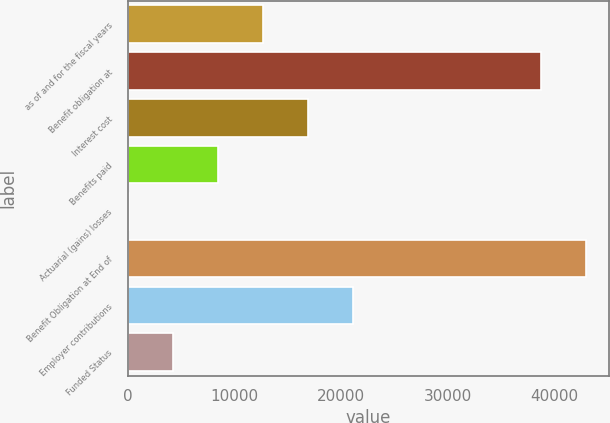Convert chart. <chart><loc_0><loc_0><loc_500><loc_500><bar_chart><fcel>as of and for the fiscal years<fcel>Benefit obligation at<fcel>Interest cost<fcel>Benefits paid<fcel>Actuarial (gains) losses<fcel>Benefit Obligation at End of<fcel>Employer contributions<fcel>Funded Status<nl><fcel>12690.2<fcel>38736<fcel>16888.6<fcel>8491.8<fcel>95<fcel>42934.4<fcel>21087<fcel>4293.4<nl></chart> 